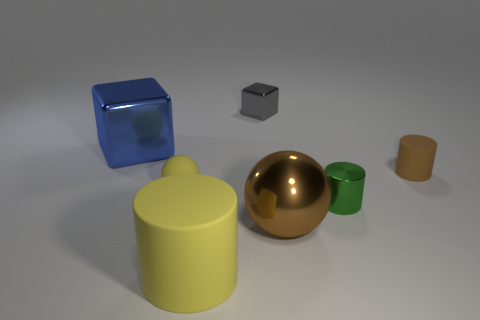Are there fewer big cylinders than spheres?
Provide a short and direct response. Yes. Is the number of yellow matte spheres that are behind the big brown object greater than the number of tiny cylinders that are in front of the big yellow thing?
Give a very brief answer. Yes. Are the green thing and the large blue object made of the same material?
Make the answer very short. Yes. There is a yellow object behind the metal ball; how many large metal objects are on the left side of it?
Make the answer very short. 1. There is a large thing right of the large yellow rubber object; does it have the same color as the small rubber cylinder?
Offer a terse response. Yes. How many things are either brown shiny things or shiny things left of the big brown ball?
Provide a short and direct response. 3. Is the shape of the tiny metal thing that is right of the gray block the same as the yellow object that is behind the tiny green thing?
Offer a very short reply. No. Is there anything else that has the same color as the big matte thing?
Keep it short and to the point. Yes. There is a small brown thing that is made of the same material as the tiny yellow object; what shape is it?
Give a very brief answer. Cylinder. There is a large object that is behind the yellow rubber cylinder and on the right side of the blue cube; what is its material?
Offer a terse response. Metal. 